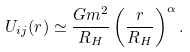Convert formula to latex. <formula><loc_0><loc_0><loc_500><loc_500>U _ { i j } ( r ) \simeq \frac { G m ^ { 2 } } { R _ { H } } \left ( \frac { r } { R _ { H } } \right ) ^ { \alpha } .</formula> 